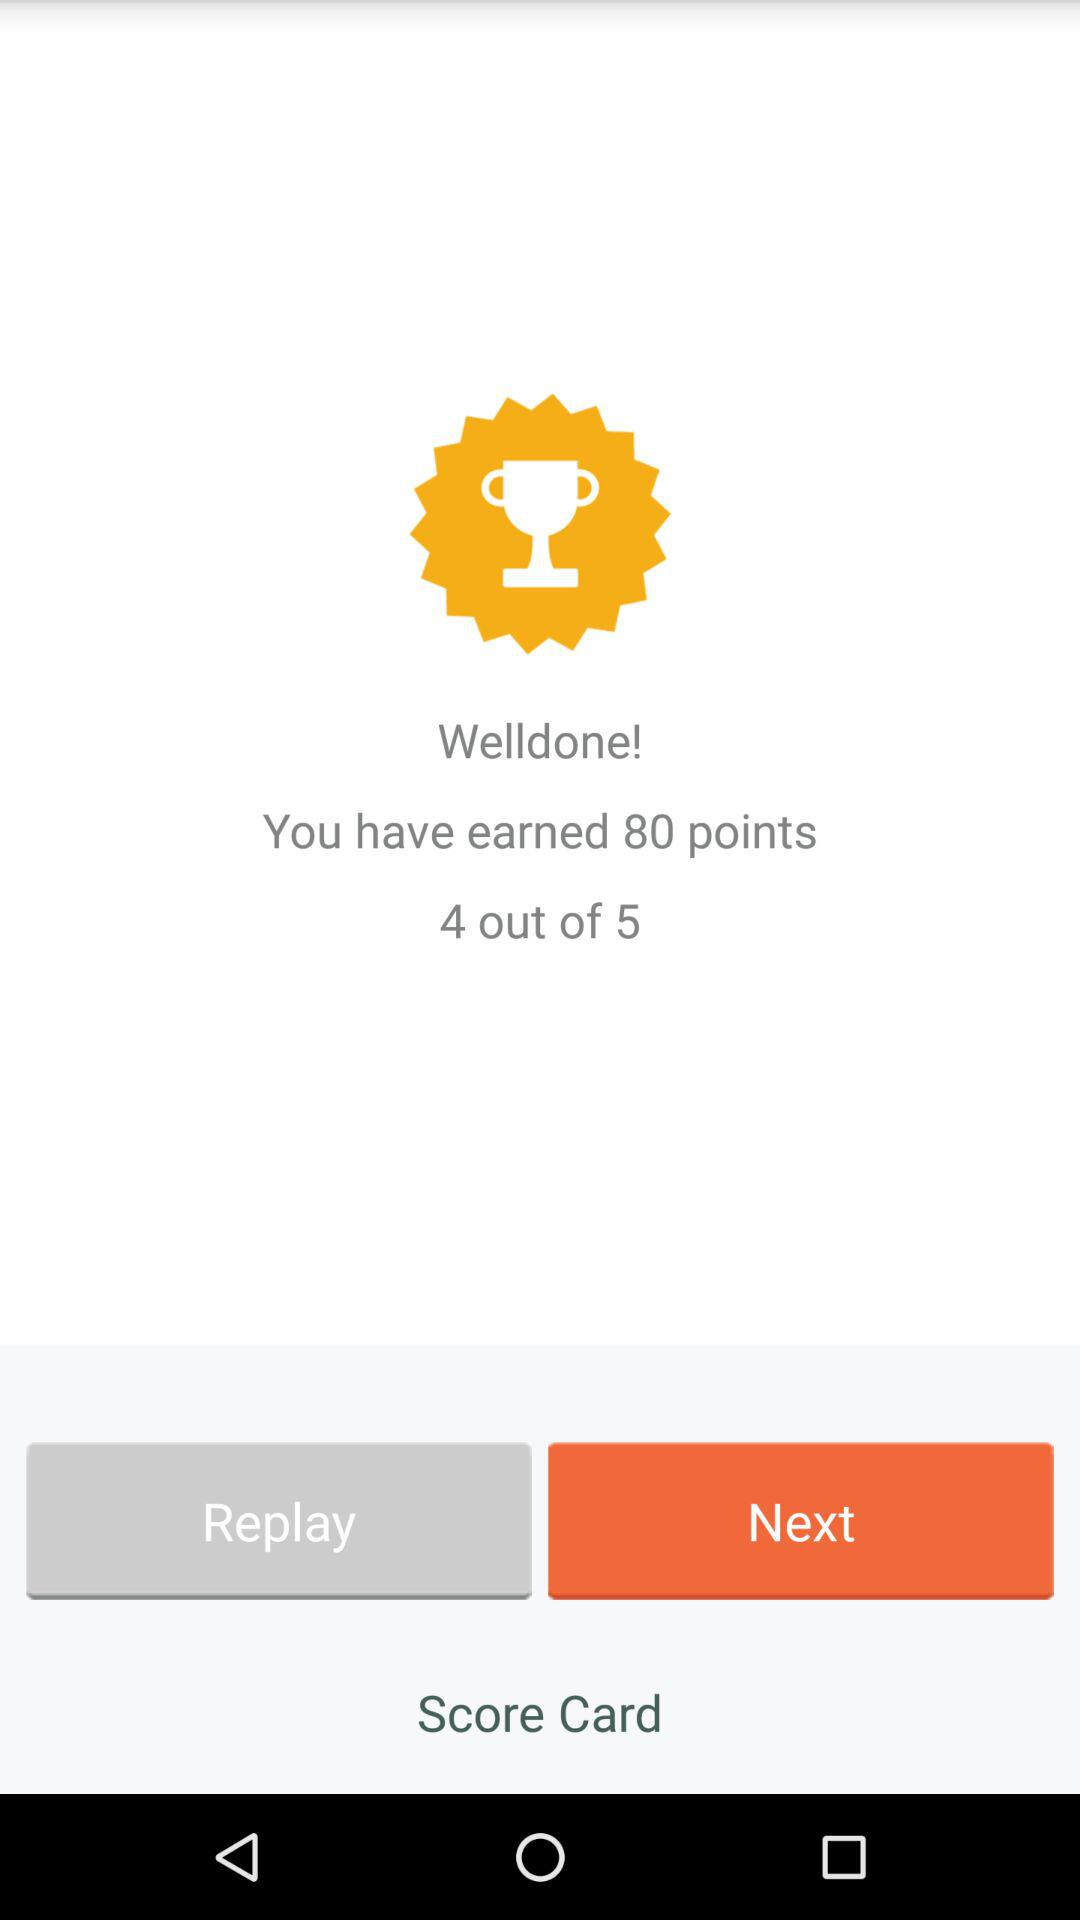At which part are we?
When the provided information is insufficient, respond with <no answer>. <no answer> 